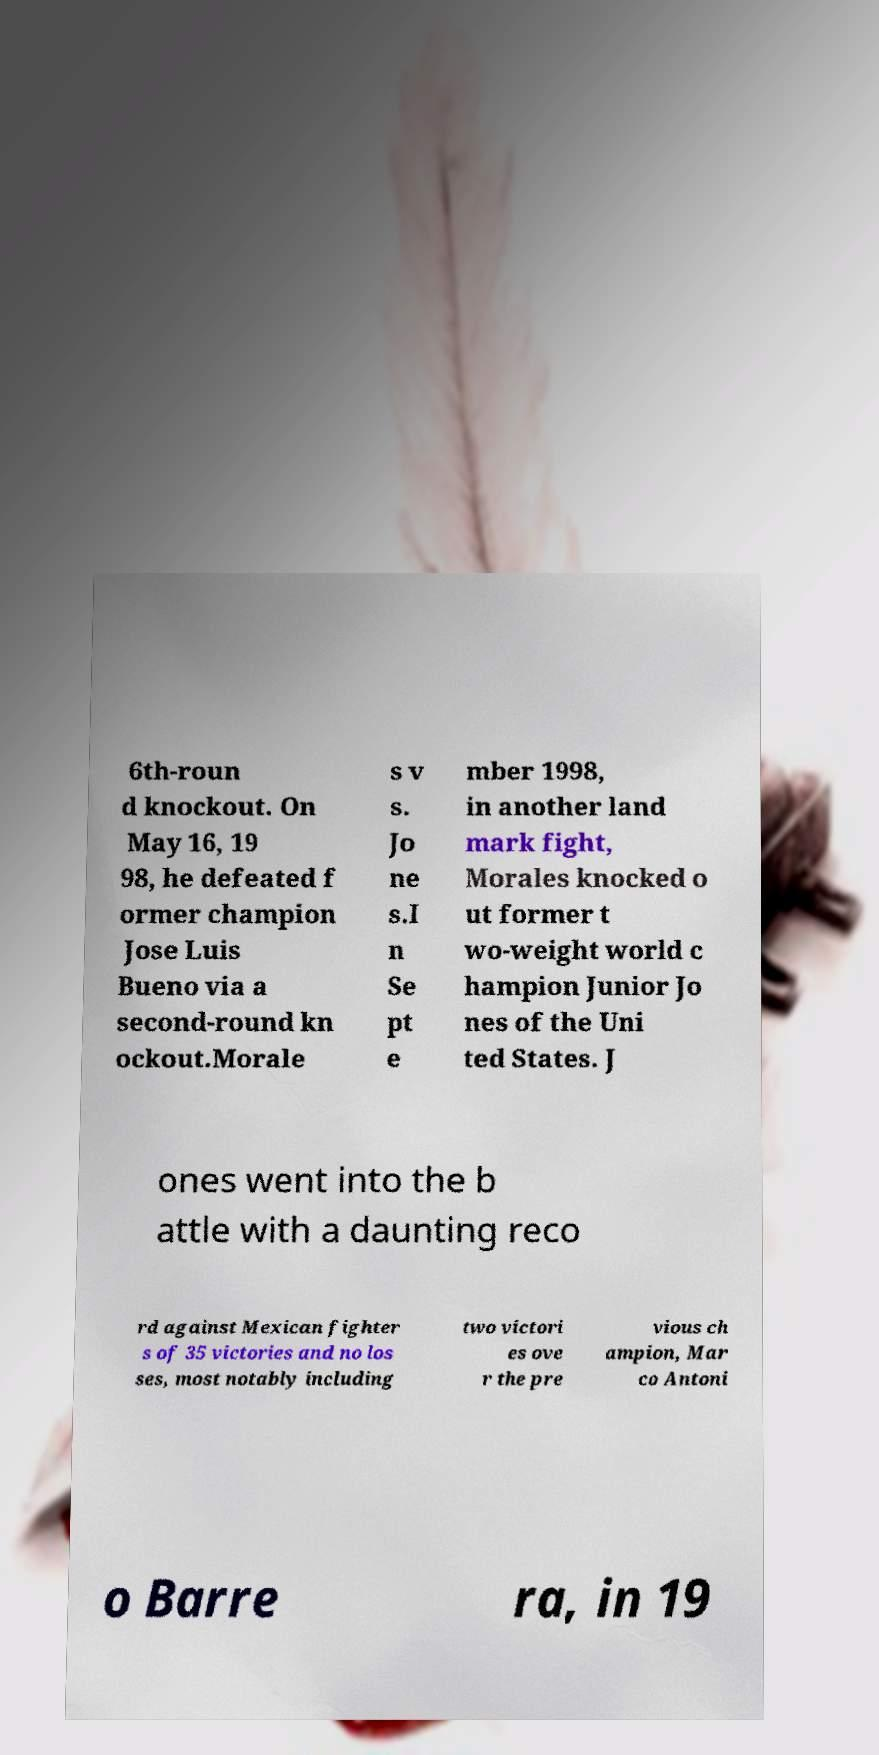For documentation purposes, I need the text within this image transcribed. Could you provide that? 6th-roun d knockout. On May 16, 19 98, he defeated f ormer champion Jose Luis Bueno via a second-round kn ockout.Morale s v s. Jo ne s.I n Se pt e mber 1998, in another land mark fight, Morales knocked o ut former t wo-weight world c hampion Junior Jo nes of the Uni ted States. J ones went into the b attle with a daunting reco rd against Mexican fighter s of 35 victories and no los ses, most notably including two victori es ove r the pre vious ch ampion, Mar co Antoni o Barre ra, in 19 